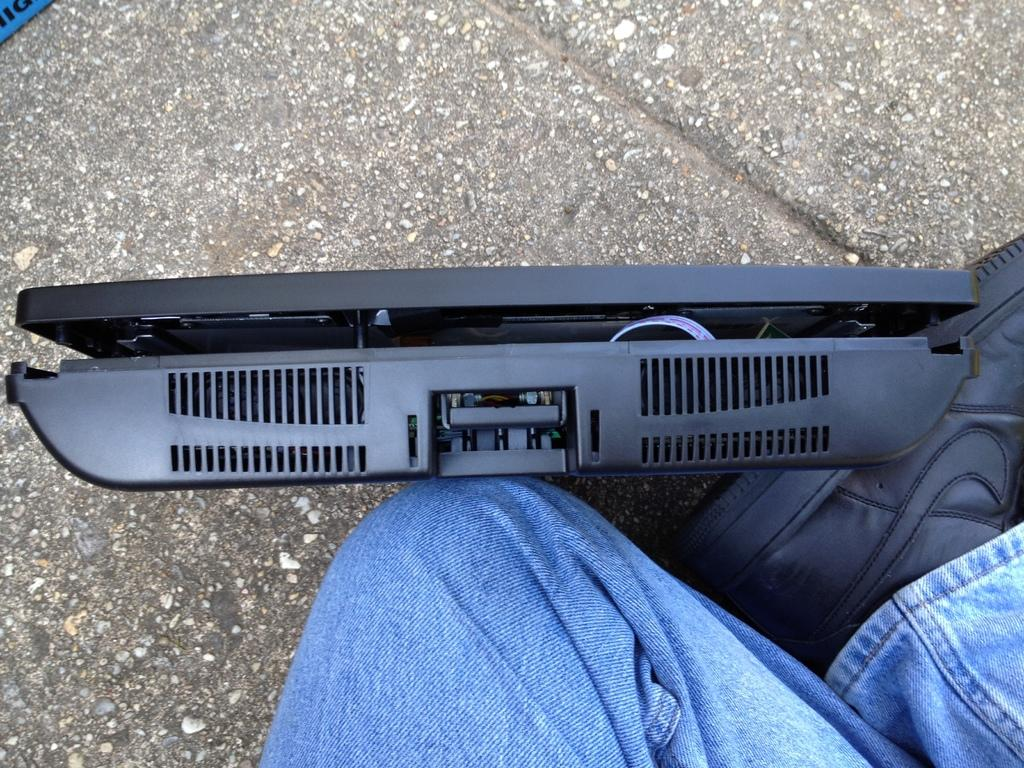What part of a person can be seen in the image? There are legs of a person in the image. What type of clothing is visible on the person's feet? Footwear is visible in the image. What can be found on the ground in the image? There is a black object on the ground in the image. What type of pets are visible in the image? There are no pets visible in the image. How many pears can be seen in the image? There are no pears present in the image. 